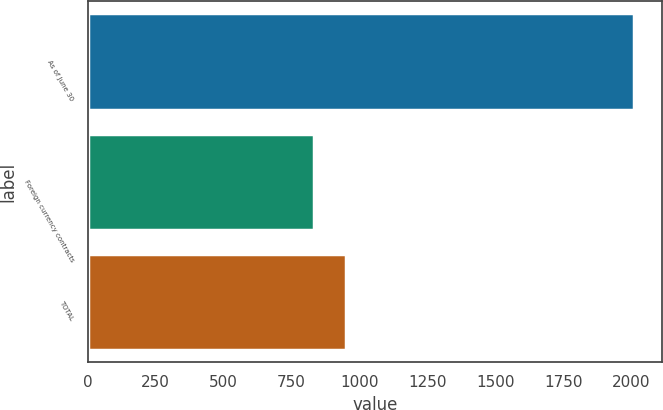Convert chart. <chart><loc_0><loc_0><loc_500><loc_500><bar_chart><fcel>As of June 30<fcel>Foreign currency contracts<fcel>TOTAL<nl><fcel>2011<fcel>831<fcel>949<nl></chart> 